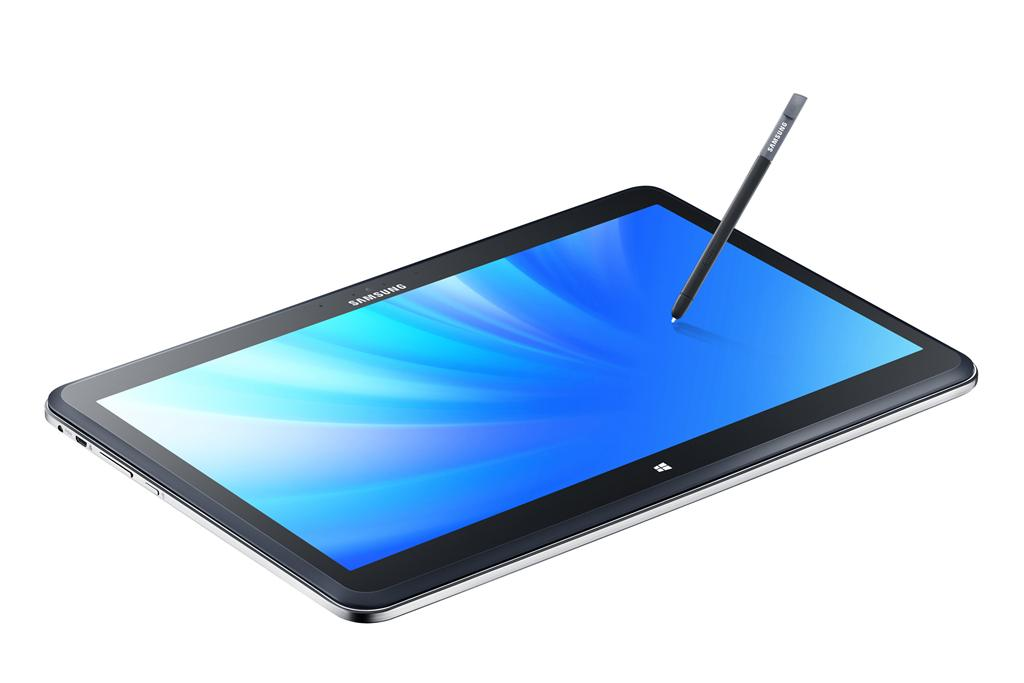What electronic device is present in the picture? There is a smartphone in the picture. What feature does the smartphone have? The smartphone has buttons. What writing instrument is in the picture? There is a pen in the picture. What is the background of the picture? There is a white backdrop in the picture. What type of sweater is the doctor wearing at the station in the image? There is no doctor, sweater, or station present in the image. 